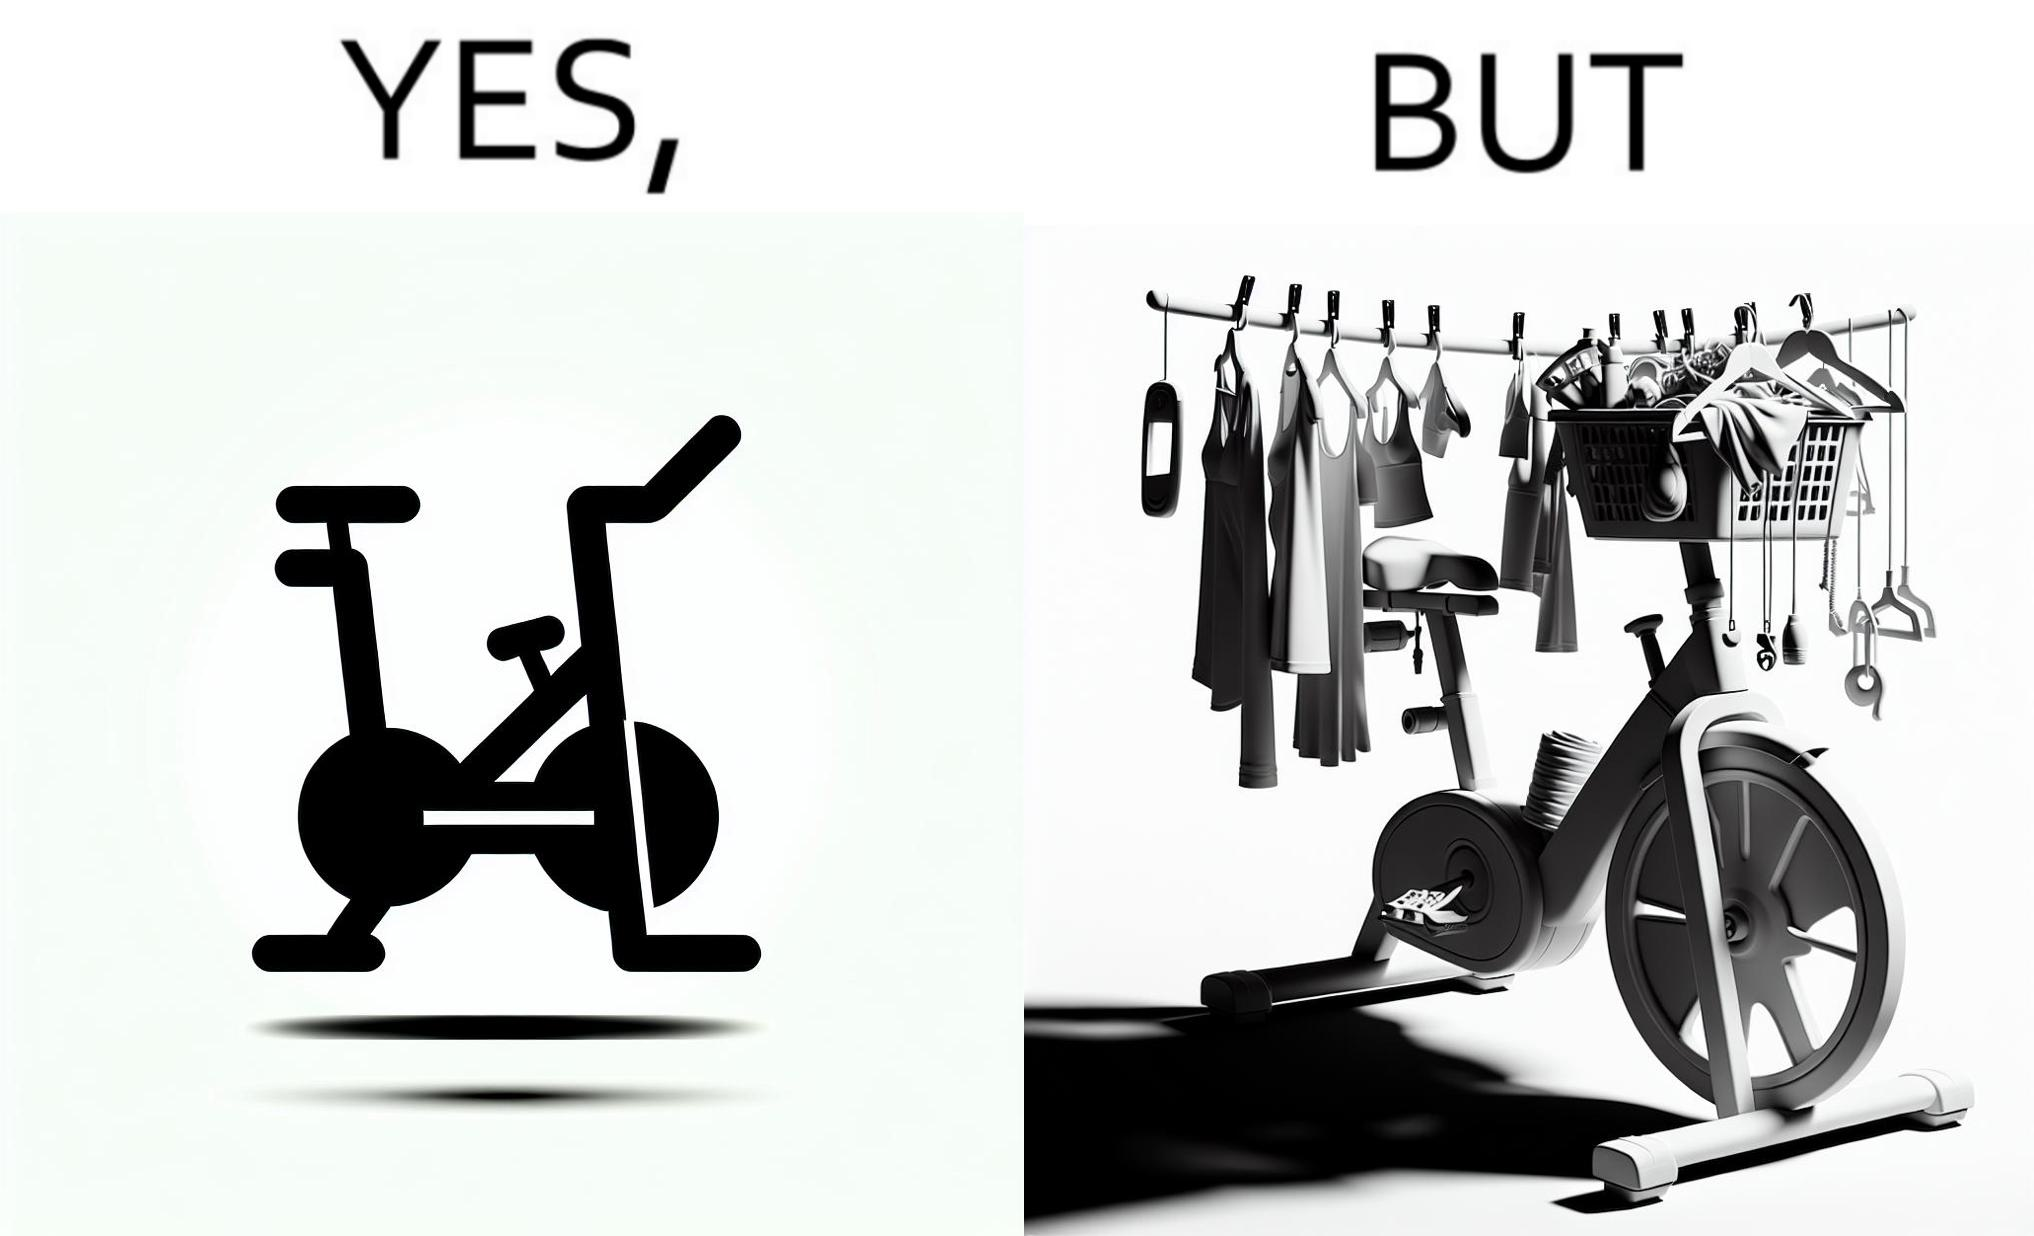Is this image satirical or non-satirical? Yes, this image is satirical. 